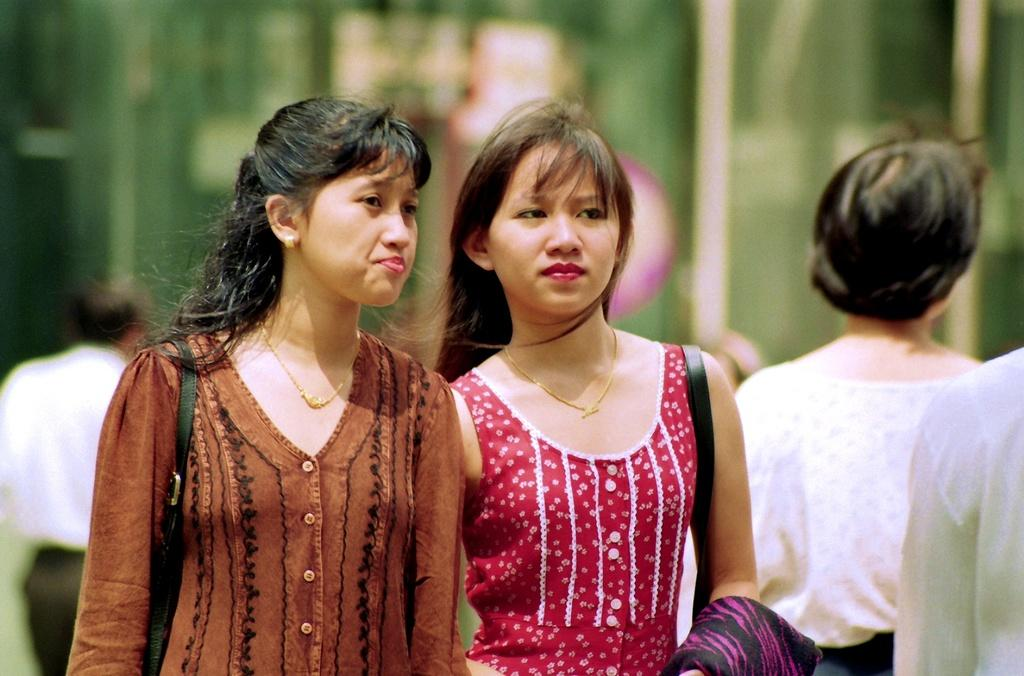What type of objects can be seen in the image? There are chains, straps, and cloth visible in the image. How many women are in the image? There are two women in the image. What can be seen in the background of the image? There are people and objects visible in the background of the image. How would you describe the quality of the background? The background is blurry. What type of farm animals can be seen in the image? There are no farm animals present in the image. Which arm of the woman on the left is holding the cloth? There is no information about the woman's arms or how she is holding the cloth in the image. 